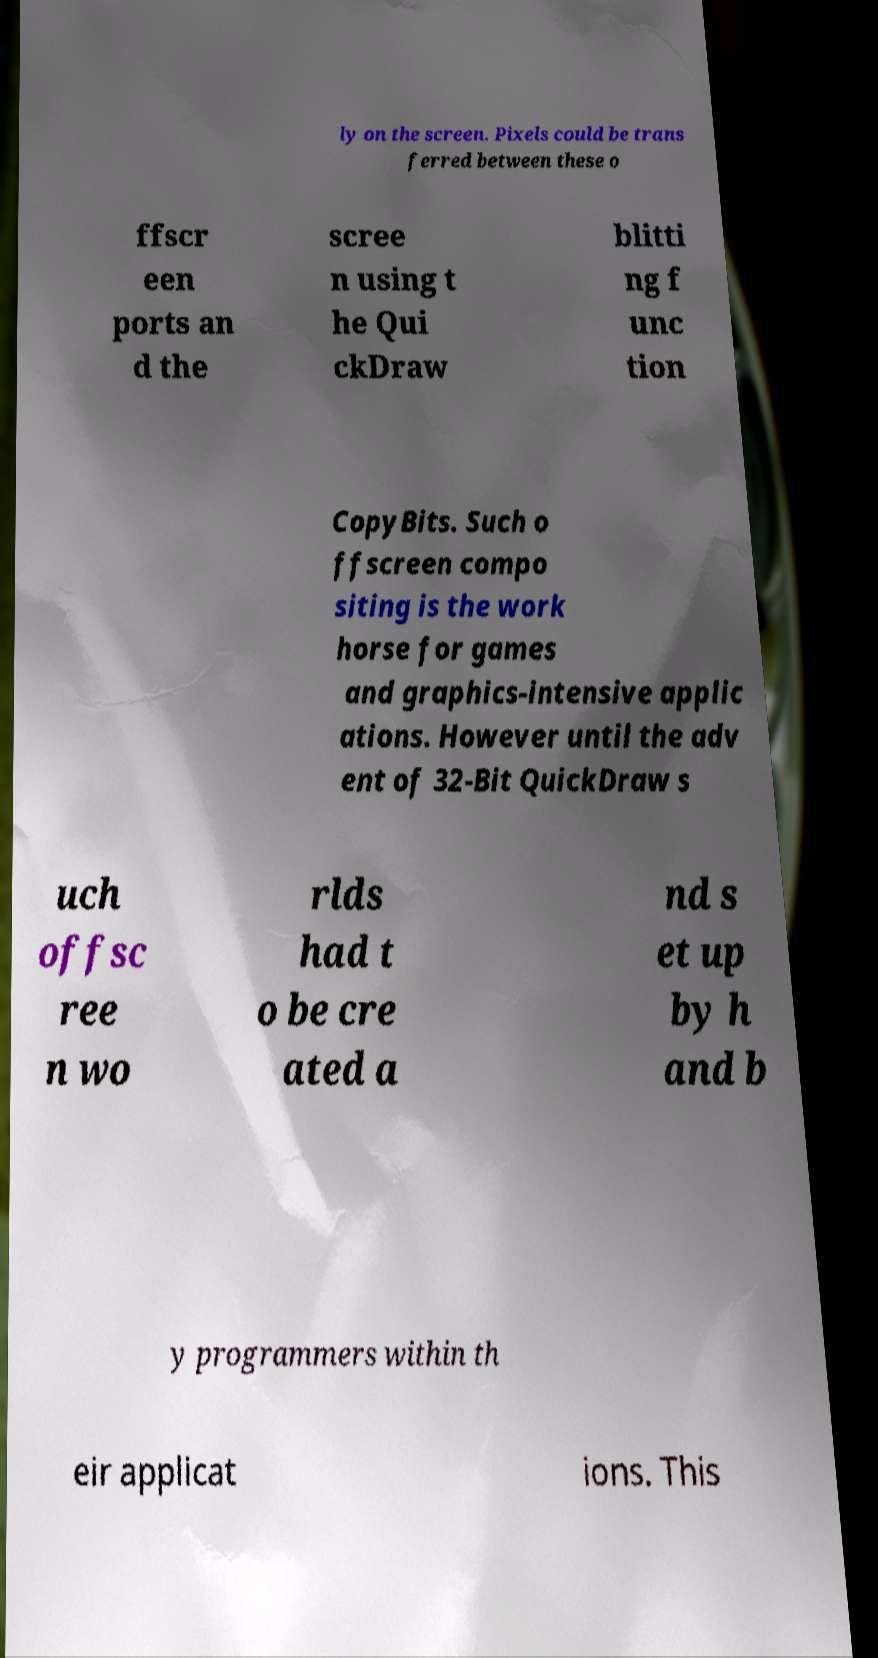Can you accurately transcribe the text from the provided image for me? ly on the screen. Pixels could be trans ferred between these o ffscr een ports an d the scree n using t he Qui ckDraw blitti ng f unc tion CopyBits. Such o ffscreen compo siting is the work horse for games and graphics-intensive applic ations. However until the adv ent of 32-Bit QuickDraw s uch offsc ree n wo rlds had t o be cre ated a nd s et up by h and b y programmers within th eir applicat ions. This 